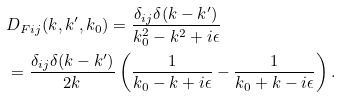<formula> <loc_0><loc_0><loc_500><loc_500>& D _ { F i j } ( k , k ^ { \prime } , k _ { 0 } ) = \frac { \delta _ { i j } \delta ( k - k ^ { \prime } ) } { k _ { 0 } ^ { 2 } - k ^ { 2 } + i \epsilon } \\ & = \frac { \delta _ { i j } \delta ( k - k ^ { \prime } ) } { 2 k } \left ( \frac { 1 } { k _ { 0 } - k + i \epsilon } - \frac { 1 } { k _ { 0 } + k - i \epsilon } \right ) .</formula> 